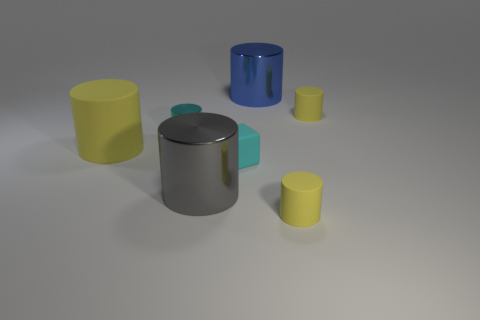Is the number of tiny rubber objects that are behind the cyan shiny cylinder the same as the number of cyan rubber things that are behind the big blue thing?
Give a very brief answer. No. Is there anything else that is the same shape as the large blue metallic object?
Ensure brevity in your answer.  Yes. Is the material of the yellow object that is on the left side of the blue object the same as the gray object?
Make the answer very short. No. There is a yellow thing that is the same size as the blue metallic cylinder; what material is it?
Your answer should be very brief. Rubber. What number of other objects are there of the same material as the gray cylinder?
Ensure brevity in your answer.  2. Do the cyan metallic cylinder and the yellow object that is in front of the big gray metallic cylinder have the same size?
Keep it short and to the point. Yes. Is the number of small cyan rubber objects on the right side of the matte cube less than the number of matte blocks that are behind the big matte cylinder?
Make the answer very short. No. What size is the rubber cylinder to the left of the large blue thing?
Your answer should be very brief. Large. Is the gray object the same size as the cyan matte thing?
Keep it short and to the point. No. How many things are both in front of the tiny cyan cylinder and left of the big gray object?
Offer a terse response. 1. 